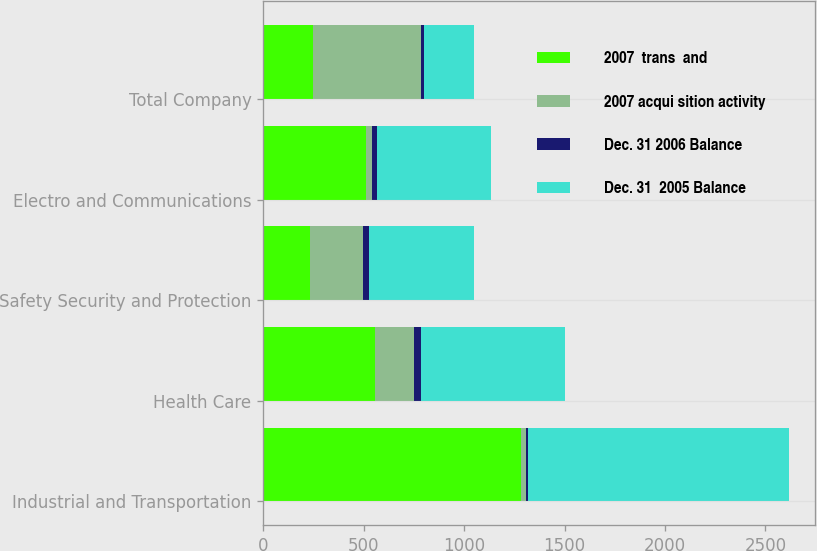<chart> <loc_0><loc_0><loc_500><loc_500><stacked_bar_chart><ecel><fcel>Industrial and Transportation<fcel>Health Care<fcel>Safety Security and Protection<fcel>Electro and Communications<fcel>Total Company<nl><fcel>2007  trans  and<fcel>1283<fcel>559<fcel>234<fcel>512<fcel>249<nl><fcel>2007 acqui sition activity<fcel>26<fcel>191<fcel>264<fcel>32<fcel>536<nl><fcel>Dec. 31 2006 Balance<fcel>7<fcel>37<fcel>27<fcel>23<fcel>16<nl><fcel>Dec. 31  2005 Balance<fcel>1302<fcel>713<fcel>525<fcel>567<fcel>249<nl></chart> 